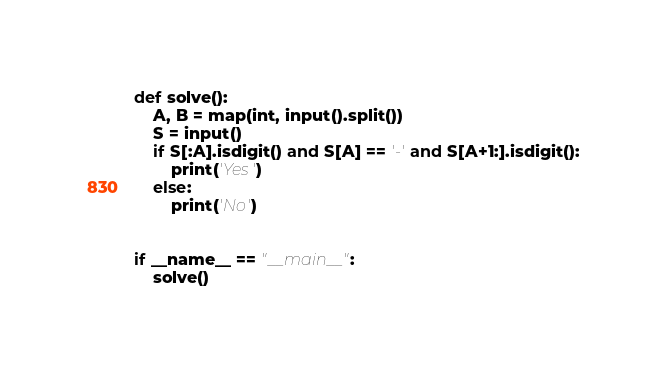Convert code to text. <code><loc_0><loc_0><loc_500><loc_500><_Python_>def solve():
    A, B = map(int, input().split())
    S = input()
    if S[:A].isdigit() and S[A] == '-' and S[A+1:].isdigit():
        print('Yes')
    else:
        print('No')


if __name__ == "__main__":
    solve()</code> 